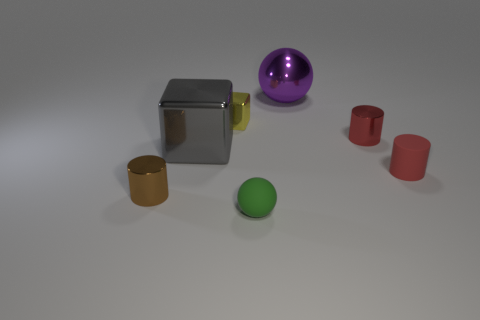Add 3 tiny green matte things. How many objects exist? 10 Subtract all balls. How many objects are left? 5 Add 4 small red rubber cylinders. How many small red rubber cylinders exist? 5 Subtract 0 brown cubes. How many objects are left? 7 Subtract all large green metal cylinders. Subtract all small objects. How many objects are left? 2 Add 5 red cylinders. How many red cylinders are left? 7 